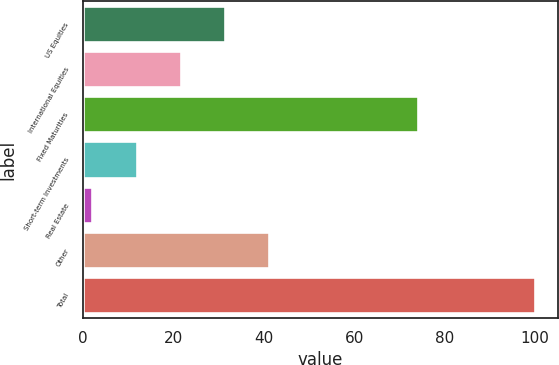<chart> <loc_0><loc_0><loc_500><loc_500><bar_chart><fcel>US Equities<fcel>International Equities<fcel>Fixed Maturities<fcel>Short-term Investments<fcel>Real Estate<fcel>Other<fcel>Total<nl><fcel>31.4<fcel>21.6<fcel>74<fcel>11.8<fcel>2<fcel>41.2<fcel>100<nl></chart> 